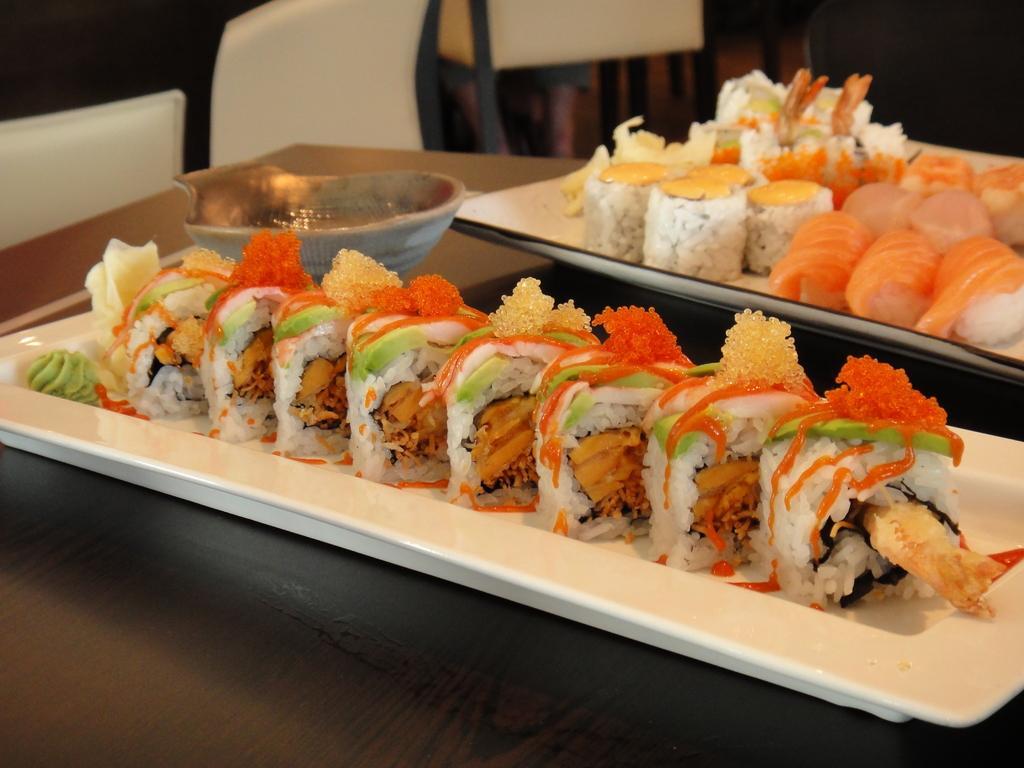Could you give a brief overview of what you see in this image? There are food items kept in a white color containers as we can see in the middle of this image. These containers are kept on a wooden surface. There are chairs at the top of this image. 